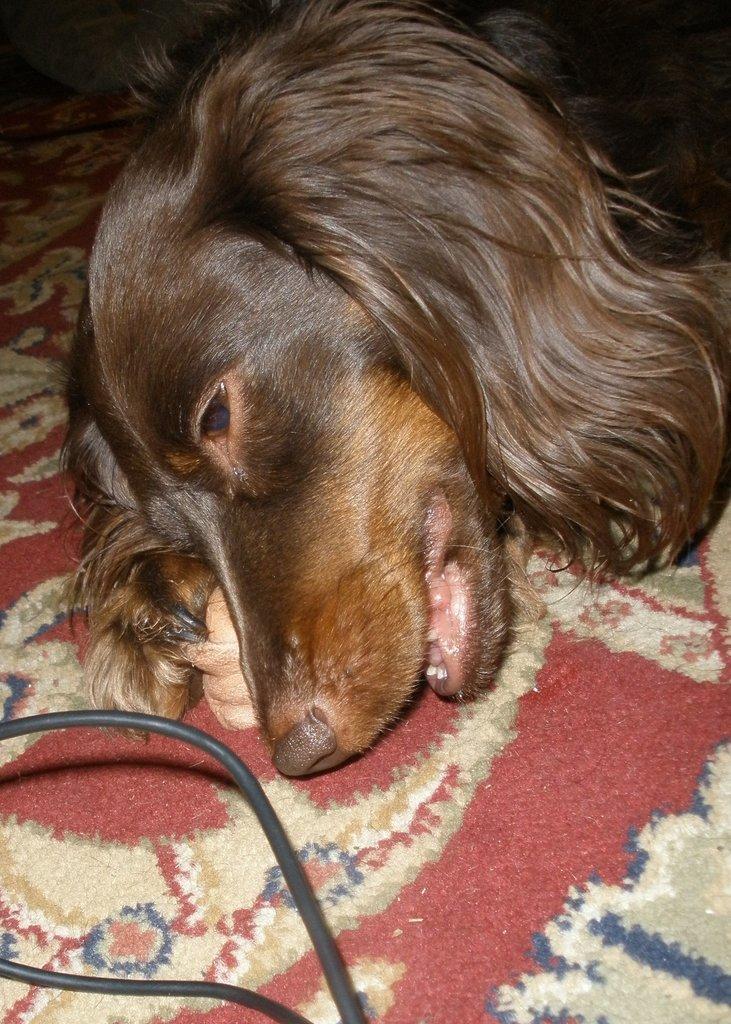Please provide a concise description of this image. In this image we can see a dog on the floor. We can also see some wires. 